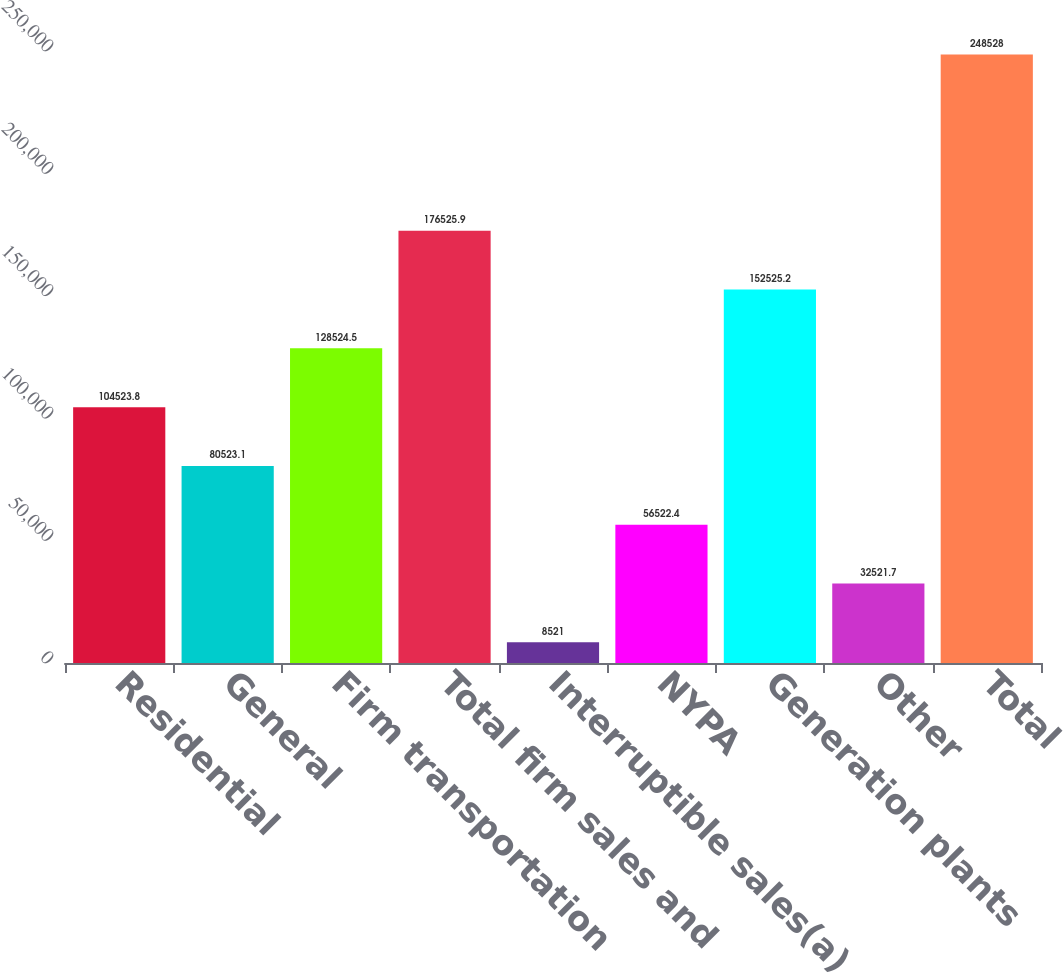<chart> <loc_0><loc_0><loc_500><loc_500><bar_chart><fcel>Residential<fcel>General<fcel>Firm transportation<fcel>Total firm sales and<fcel>Interruptible sales(a)<fcel>NYPA<fcel>Generation plants<fcel>Other<fcel>Total<nl><fcel>104524<fcel>80523.1<fcel>128524<fcel>176526<fcel>8521<fcel>56522.4<fcel>152525<fcel>32521.7<fcel>248528<nl></chart> 